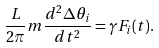<formula> <loc_0><loc_0><loc_500><loc_500>\frac { L } { 2 \pi } m \frac { d ^ { 2 } \Delta \theta _ { i } } { d t ^ { 2 } } = \gamma F _ { i } ( t ) .</formula> 